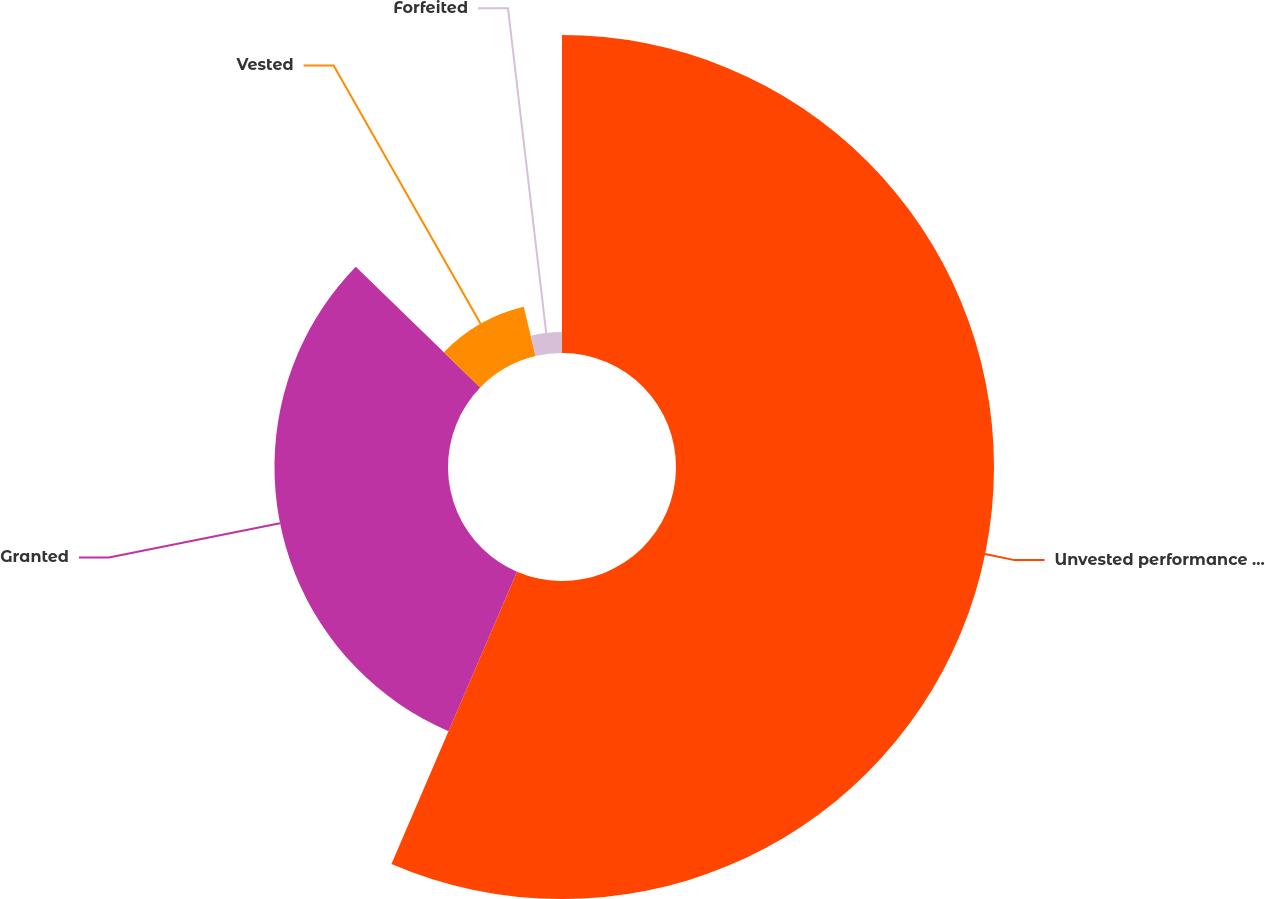Convert chart to OTSL. <chart><loc_0><loc_0><loc_500><loc_500><pie_chart><fcel>Unvested performance stock<fcel>Granted<fcel>Vested<fcel>Forfeited<nl><fcel>56.46%<fcel>30.81%<fcel>9.0%<fcel>3.73%<nl></chart> 